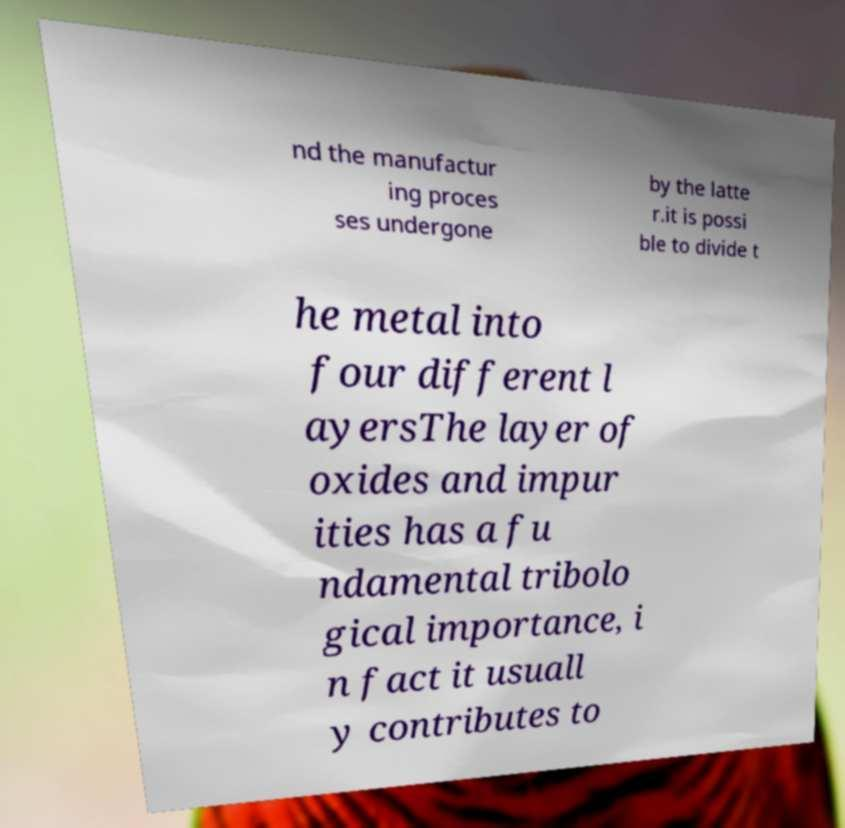Please read and relay the text visible in this image. What does it say? nd the manufactur ing proces ses undergone by the latte r.it is possi ble to divide t he metal into four different l ayersThe layer of oxides and impur ities has a fu ndamental tribolo gical importance, i n fact it usuall y contributes to 